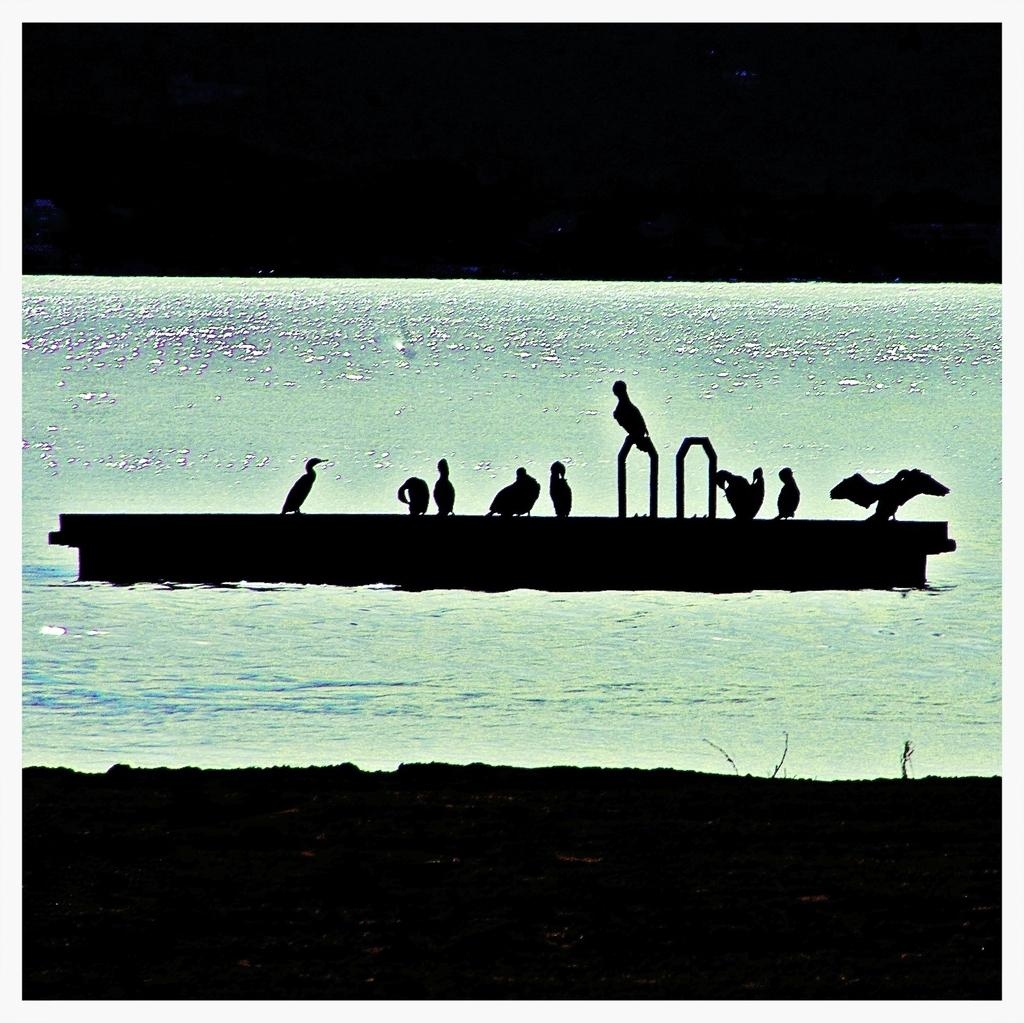What type of artwork is depicted in the image? The image is a painting. What natural element is present in the painting? There is water in the painting. What man-made object can be seen in the painting? There is a boat in the painting. What type of animals are in the painting? There are birds in the painting. What type of comb is being used by the brother in the painting? There is no brother or comb present in the painting; it features water, a boat, and birds. 